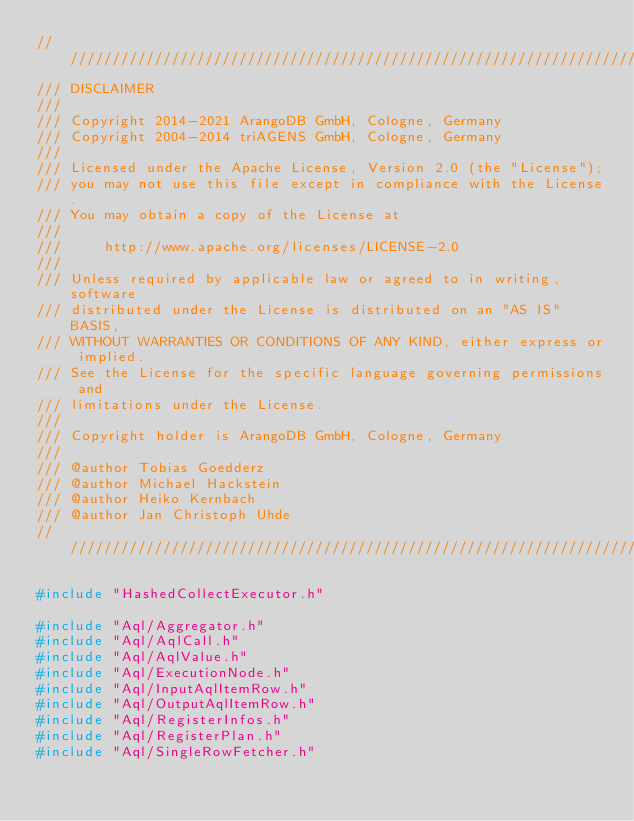Convert code to text. <code><loc_0><loc_0><loc_500><loc_500><_C++_>////////////////////////////////////////////////////////////////////////////////
/// DISCLAIMER
///
/// Copyright 2014-2021 ArangoDB GmbH, Cologne, Germany
/// Copyright 2004-2014 triAGENS GmbH, Cologne, Germany
///
/// Licensed under the Apache License, Version 2.0 (the "License");
/// you may not use this file except in compliance with the License.
/// You may obtain a copy of the License at
///
///     http://www.apache.org/licenses/LICENSE-2.0
///
/// Unless required by applicable law or agreed to in writing, software
/// distributed under the License is distributed on an "AS IS" BASIS,
/// WITHOUT WARRANTIES OR CONDITIONS OF ANY KIND, either express or implied.
/// See the License for the specific language governing permissions and
/// limitations under the License.
///
/// Copyright holder is ArangoDB GmbH, Cologne, Germany
///
/// @author Tobias Goedderz
/// @author Michael Hackstein
/// @author Heiko Kernbach
/// @author Jan Christoph Uhde
////////////////////////////////////////////////////////////////////////////////

#include "HashedCollectExecutor.h"

#include "Aql/Aggregator.h"
#include "Aql/AqlCall.h"
#include "Aql/AqlValue.h"
#include "Aql/ExecutionNode.h"
#include "Aql/InputAqlItemRow.h"
#include "Aql/OutputAqlItemRow.h"
#include "Aql/RegisterInfos.h"
#include "Aql/RegisterPlan.h"
#include "Aql/SingleRowFetcher.h"</code> 